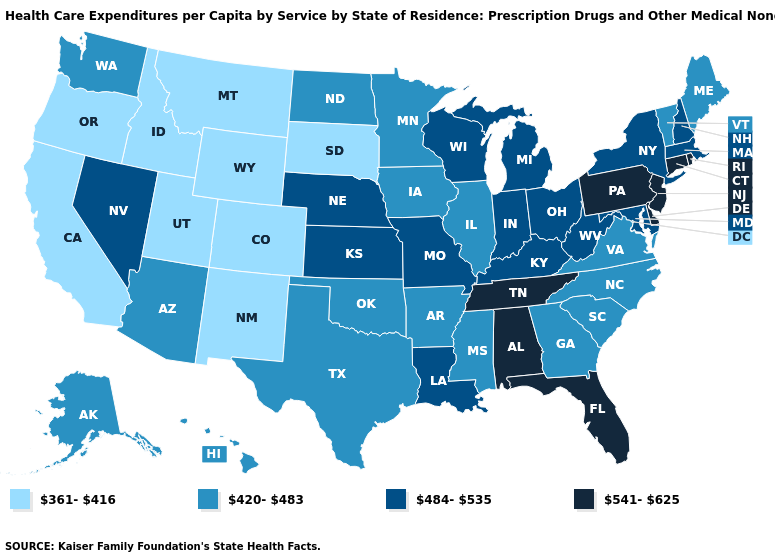Is the legend a continuous bar?
Keep it brief. No. Among the states that border Delaware , which have the lowest value?
Give a very brief answer. Maryland. What is the value of Oklahoma?
Quick response, please. 420-483. Name the states that have a value in the range 541-625?
Answer briefly. Alabama, Connecticut, Delaware, Florida, New Jersey, Pennsylvania, Rhode Island, Tennessee. What is the value of New York?
Give a very brief answer. 484-535. Does South Carolina have the lowest value in the USA?
Concise answer only. No. Does Alaska have the highest value in the West?
Quick response, please. No. Name the states that have a value in the range 541-625?
Short answer required. Alabama, Connecticut, Delaware, Florida, New Jersey, Pennsylvania, Rhode Island, Tennessee. What is the lowest value in states that border Utah?
Concise answer only. 361-416. What is the highest value in states that border Texas?
Be succinct. 484-535. What is the value of Colorado?
Quick response, please. 361-416. Among the states that border Oregon , which have the lowest value?
Keep it brief. California, Idaho. Which states have the highest value in the USA?
Quick response, please. Alabama, Connecticut, Delaware, Florida, New Jersey, Pennsylvania, Rhode Island, Tennessee. Among the states that border Colorado , which have the highest value?
Give a very brief answer. Kansas, Nebraska. Does Rhode Island have the same value as Florida?
Short answer required. Yes. 